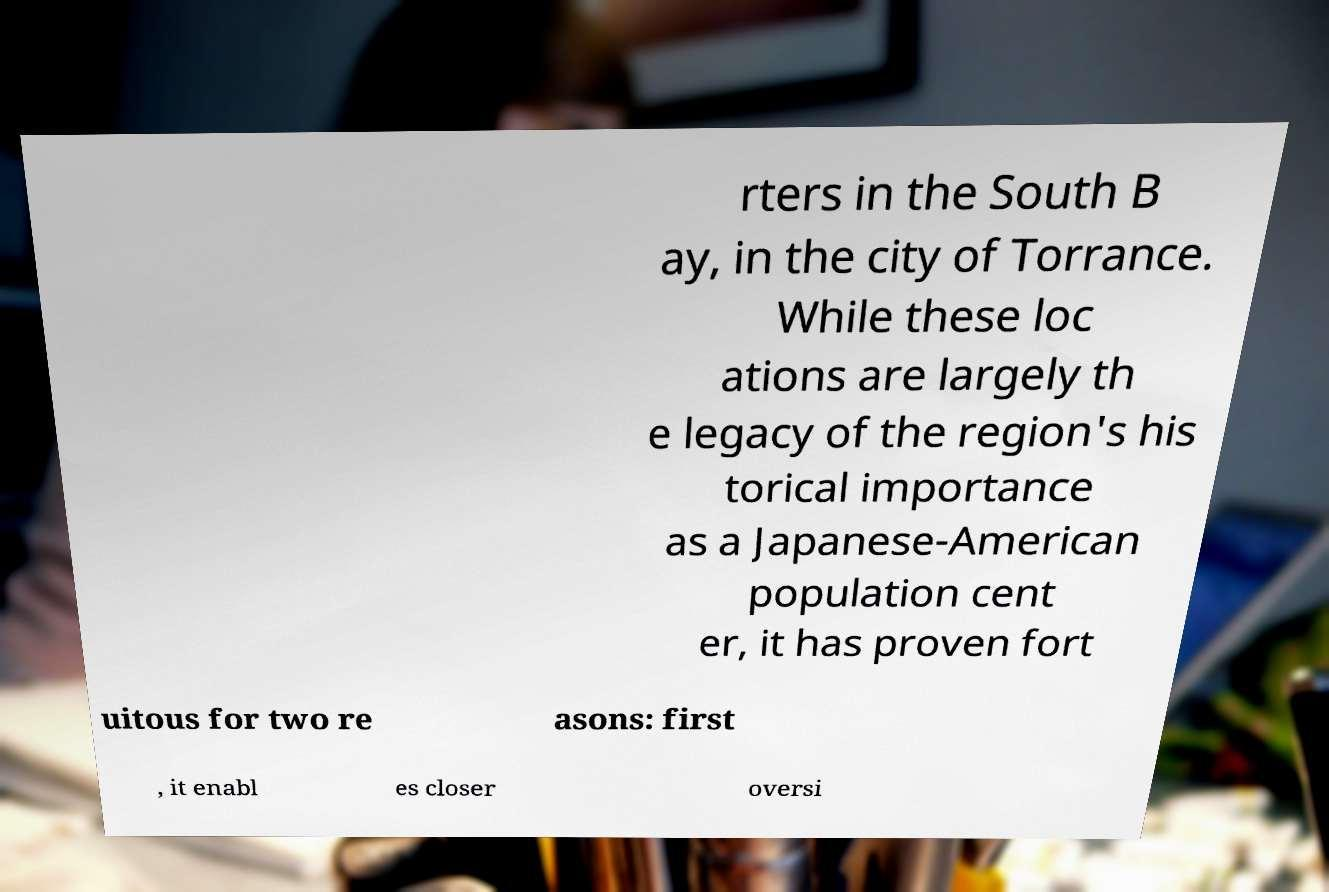Please identify and transcribe the text found in this image. rters in the South B ay, in the city of Torrance. While these loc ations are largely th e legacy of the region's his torical importance as a Japanese-American population cent er, it has proven fort uitous for two re asons: first , it enabl es closer oversi 